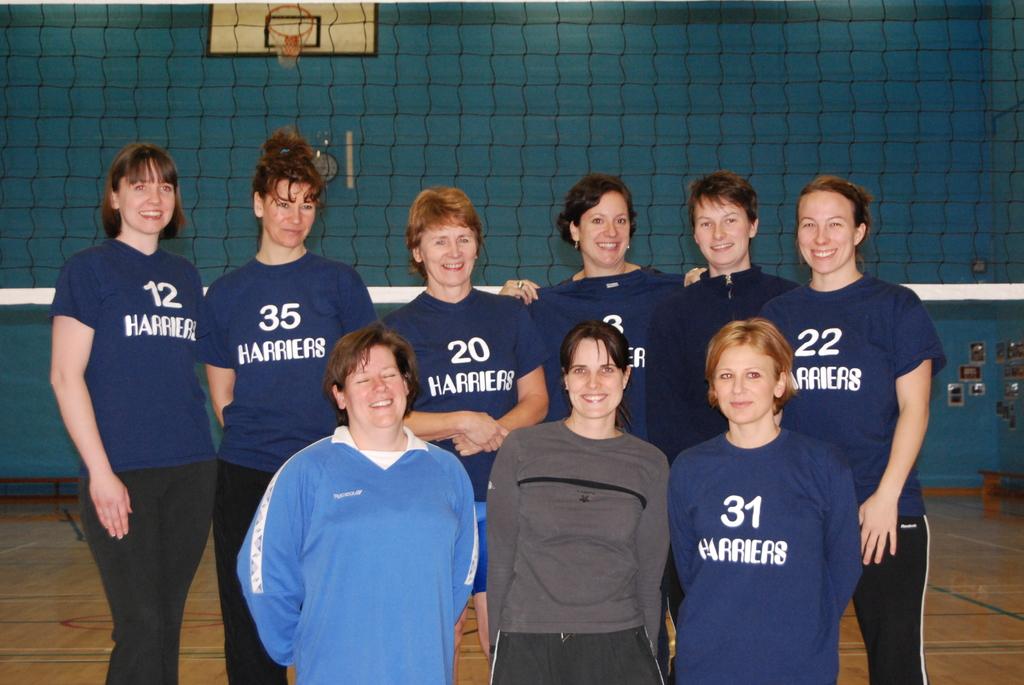Which number of player is on the bottom right?
Your answer should be compact. 31. 